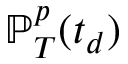<formula> <loc_0><loc_0><loc_500><loc_500>\mathbb { P } _ { T } ^ { p } ( t _ { d } )</formula> 